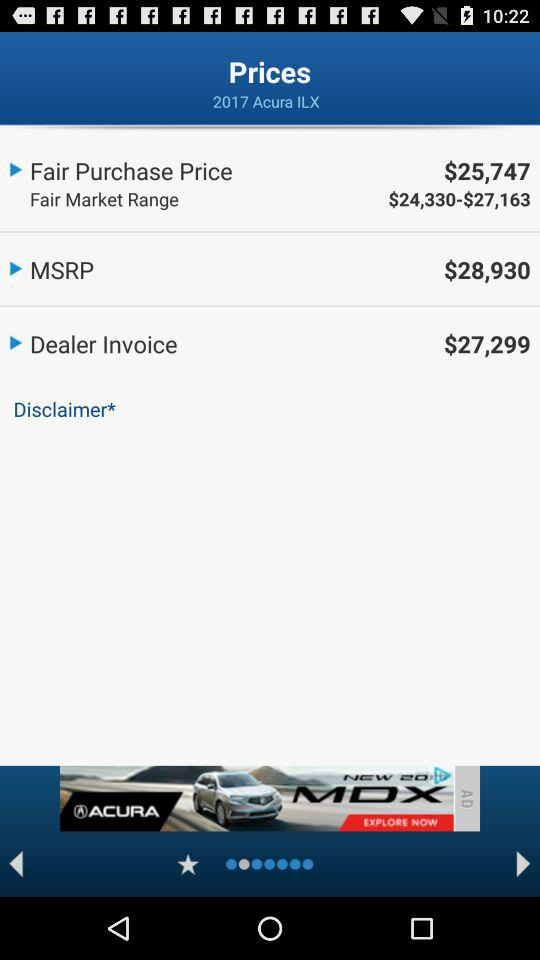What is the fair purchase price of the "2017 Acura ILX"? The fair purchase price of the "2017 Acura ILX" is $25,747. 